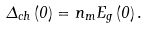<formula> <loc_0><loc_0><loc_500><loc_500>\Delta _ { c h } \left ( { 0 } \right ) = n _ { m } E _ { g } \left ( { 0 } \right ) .</formula> 